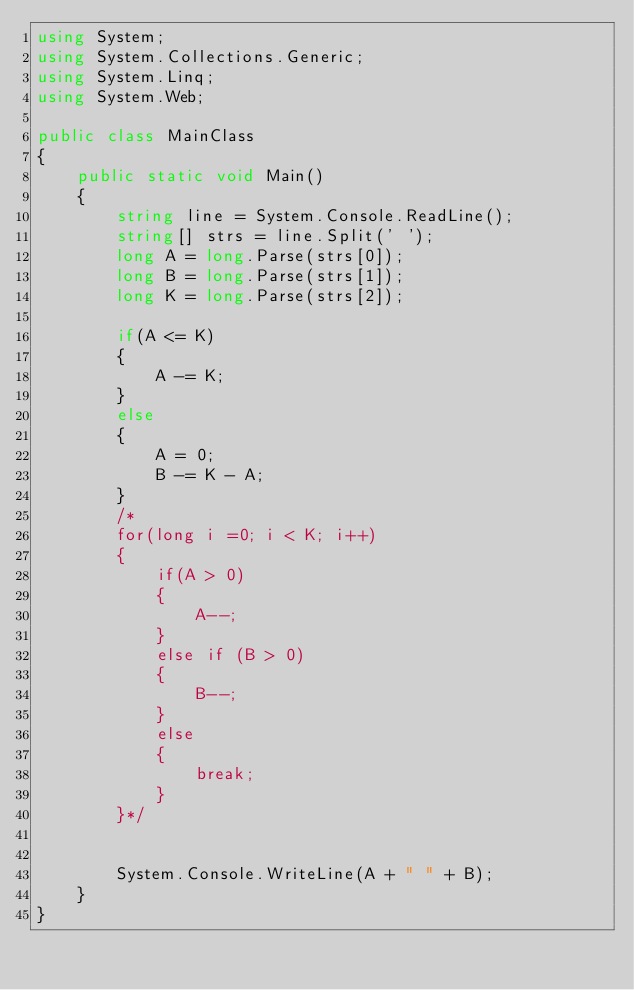<code> <loc_0><loc_0><loc_500><loc_500><_C#_>using System;
using System.Collections.Generic;
using System.Linq;
using System.Web;

public class MainClass
{
    public static void Main()
    {
        string line = System.Console.ReadLine();
        string[] strs = line.Split(' ');
        long A = long.Parse(strs[0]);
        long B = long.Parse(strs[1]);
        long K = long.Parse(strs[2]);

        if(A <= K)
        {
            A -= K;
        }
        else
        {
            A = 0;
            B -= K - A;
        }
        /*
        for(long i =0; i < K; i++)
        {
            if(A > 0)
            {
                A--;
            }
            else if (B > 0)
            {
                B--;
            }
            else
            {
                break;
            }
        }*/


        System.Console.WriteLine(A + " " + B);
    }
}</code> 